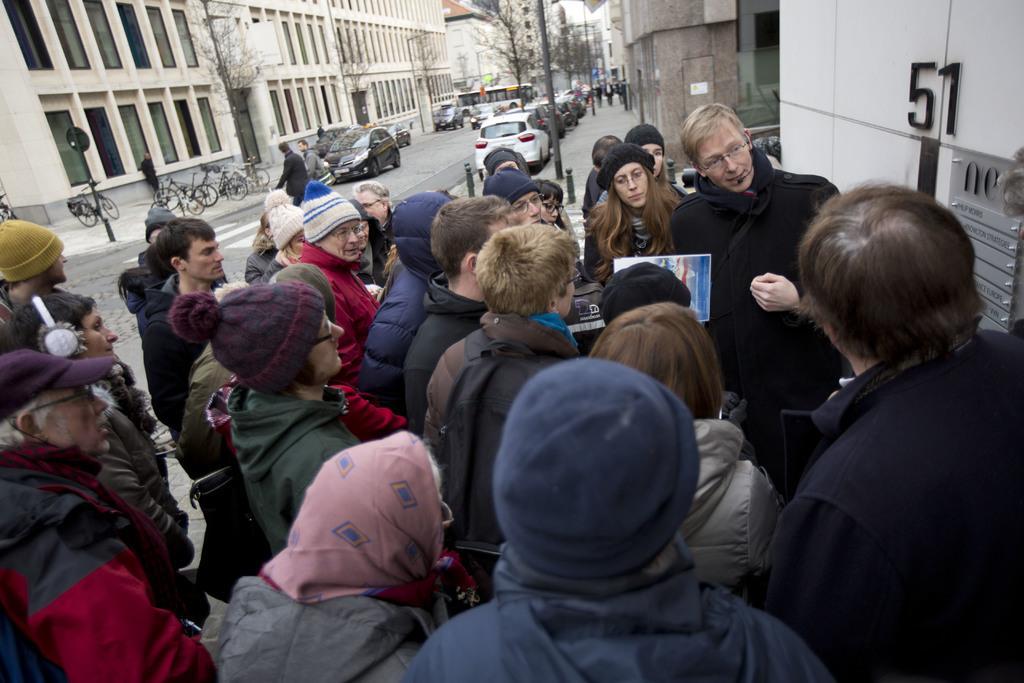How would you summarize this image in a sentence or two? Here in the front we can see number of people standing on the road over there, we can see all of them are wearing jackets and caps on them and the person in the middle is speaking something in the microphone present with him and in front of them we can see a wall, on which we can see something present and behind them we can see number of cars and bicycles present on the road over there and we can also see people walking on the road here and there and we can also see light posts, sign boards and buildings and trees present all over there. 